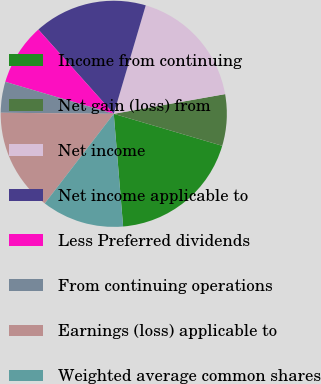Convert chart. <chart><loc_0><loc_0><loc_500><loc_500><pie_chart><fcel>Income from continuing<fcel>Net gain (loss) from<fcel>Net income<fcel>Net income applicable to<fcel>Less Preferred dividends<fcel>From continuing operations<fcel>Earnings (loss) applicable to<fcel>Weighted average common shares<nl><fcel>19.12%<fcel>7.35%<fcel>17.65%<fcel>16.18%<fcel>8.82%<fcel>4.41%<fcel>14.71%<fcel>11.76%<nl></chart> 